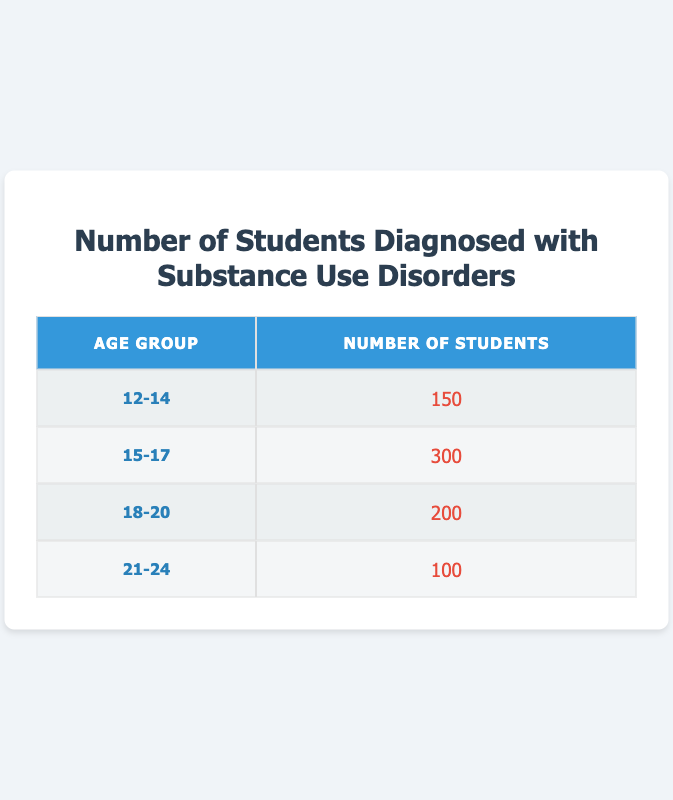What is the total number of students diagnosed with substance use disorders across all age groups? To find the total number, we add the number of students in each age group: 150 (12-14) + 300 (15-17) + 200 (18-20) + 100 (21-24) = 750.
Answer: 750 Which age group has the highest number of students diagnosed with substance use disorders? The age group with the highest number is 15-17, which has 300 students diagnosed.
Answer: 15-17 What is the number of students diagnosed with substance use disorders in the 18-20 age group? The table indicates that there are 200 students diagnosed with substance use disorders in the 18-20 age group.
Answer: 200 Is the number of students diagnosed with substance use disorders higher in the 15-17 age group than in the 12-14 age group? Yes, the 15-17 age group has 300 students, while the 12-14 age group has only 150 students.
Answer: Yes What is the difference in the number of students diagnosed between the 15-17 and 21-24 age groups? The difference is calculated by subtracting the number of students in the 21-24 age group from the 15-17 age group: 300 (15-17) - 100 (21-24) = 200.
Answer: 200 What percentage of the total diagnosed students fall in the 12-14 age group? We first find the proportion of the 12-14 age group to the total: (150 / 750) * 100 = 20%.
Answer: 20% How many more students are diagnosed in the 15-17 age group compared to the 21-24 age group? The number in the 15-17 age group is 300 and in the 21-24 age group is 100. The difference is 300 - 100 = 200.
Answer: 200 Are there any age groups in which the number of students is less than 200? Yes, both the 12-14 age group (150) and the 21-24 age group (100) have fewer than 200 students diagnosed.
Answer: Yes What is the average number of students diagnosed with substance use disorders across all age groups? To find the average, we total the students (750) and divide by the number of age groups (4): 750 / 4 = 187.5.
Answer: 187.5 